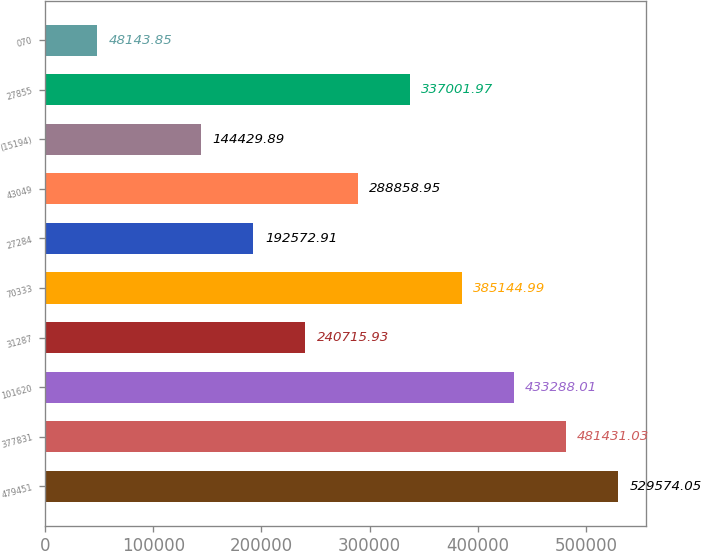Convert chart. <chart><loc_0><loc_0><loc_500><loc_500><bar_chart><fcel>479451<fcel>377831<fcel>101620<fcel>31287<fcel>70333<fcel>27284<fcel>43049<fcel>(15194)<fcel>27855<fcel>070<nl><fcel>529574<fcel>481431<fcel>433288<fcel>240716<fcel>385145<fcel>192573<fcel>288859<fcel>144430<fcel>337002<fcel>48143.8<nl></chart> 